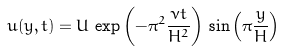Convert formula to latex. <formula><loc_0><loc_0><loc_500><loc_500>u ( y , t ) = U \, \exp \left ( - \pi ^ { 2 } \frac { \nu t } { H ^ { 2 } } \right ) \, \sin \left ( \pi \frac { y } { H } \right )</formula> 